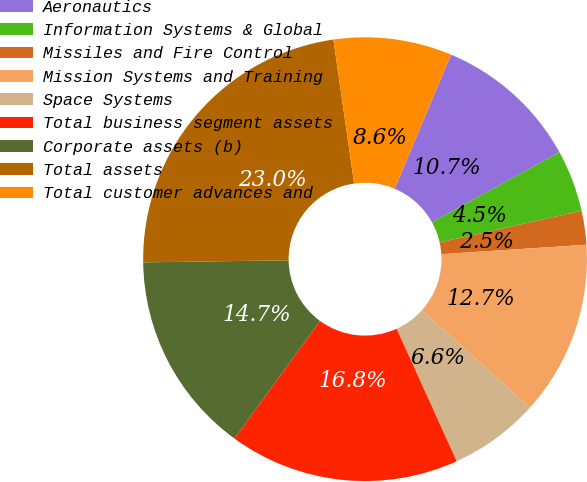Convert chart to OTSL. <chart><loc_0><loc_0><loc_500><loc_500><pie_chart><fcel>Aeronautics<fcel>Information Systems & Global<fcel>Missiles and Fire Control<fcel>Mission Systems and Training<fcel>Space Systems<fcel>Total business segment assets<fcel>Corporate assets (b)<fcel>Total assets<fcel>Total customer advances and<nl><fcel>10.66%<fcel>4.51%<fcel>2.46%<fcel>12.7%<fcel>6.56%<fcel>16.8%<fcel>14.75%<fcel>22.95%<fcel>8.61%<nl></chart> 